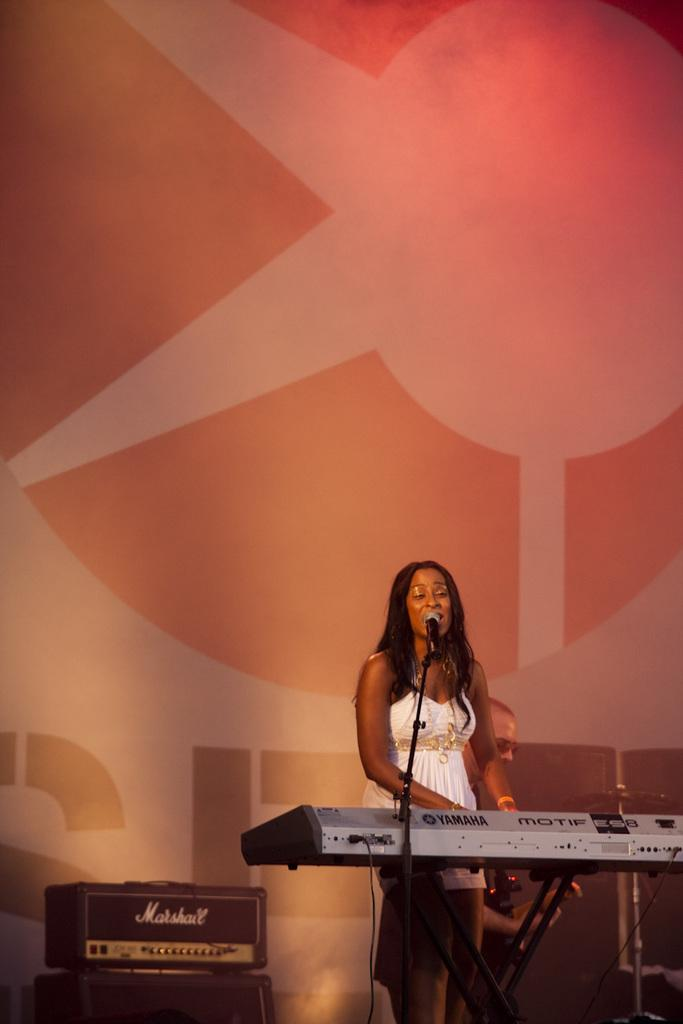What is the main subject of the image? There is a person in the image. What is the person doing in the image? The person is playing a musical instrument (the mic). Can you describe any other objects or elements in the image? There is an unspecified thing in the image. What type of gun can be seen in the image? There is no gun present in the image. What flavor of juice is being consumed by the person in the image? There is no juice present in the image. 